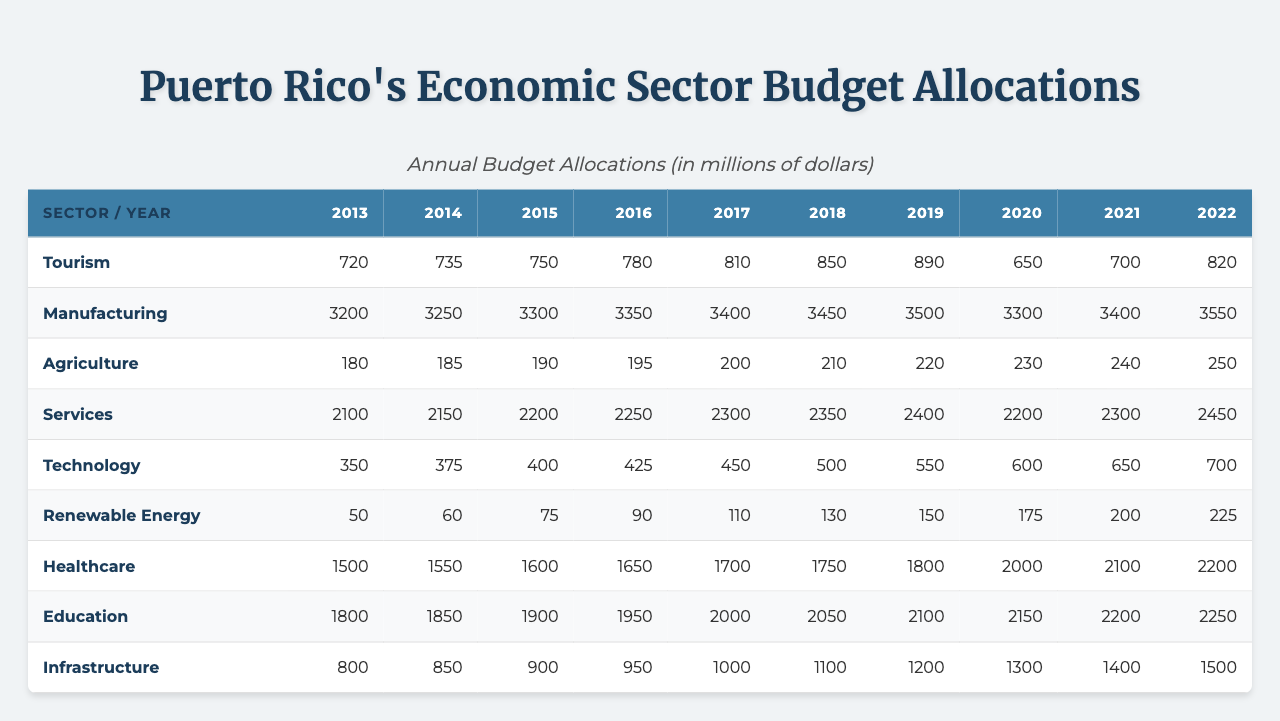What was the budget allocation for Healthcare in 2020? The table shows that the budget allocation for Healthcare in 2020 was 2000 million dollars.
Answer: 2000 million dollars In which year did the Agriculture sector see the highest budget allocation? The highest budget allocation for Agriculture was 250 million dollars in 2022, as observed in the table.
Answer: 2022 What was the total budget allocation for the Education sector from 2013 to 2022? By summing the values for Education from 2013 to 2022, (1800 + 1850 + 1900 + 1950 + 2000 + 2050 + 2100 + 2150 + 2200 + 2250) = 20,250 million dollars.
Answer: 20,250 million dollars Did the budget for Renewable Energy increase every year? The table indicates that the budget for Renewable Energy increased each year from 2013 to 2022, showing consistent growth.
Answer: Yes What is the average budget allocation for the Manufacturing sector over the decade? The total for Manufacturing is (3200 + 3250 + 3300 + 3350 + 3400 + 3450 + 3500 + 3300 + 3400 + 3550) = 34,600 million dollars; dividing this by the 10 years gives an average of 3460 million dollars.
Answer: 3460 million dollars Which sector had the lowest budget allocation in 2019? In 2019, the sector with the lowest budget allocation was Renewable Energy, with an allocation of 150 million dollars, as the table shows.
Answer: Renewable Energy How much more was allocated to the Services sector than the Agriculture sector in 2021? In 2021, the Services sector had an allocation of 2300 million dollars while Agriculture had 240 million dollars. The difference is (2300 - 240 = 2060) million dollars.
Answer: 2060 million dollars In which year did the Technology sector cross the 500 million dollar budget allocation? As per the table, the Technology sector crossed the 500 million dollar mark in 2018 when the allocation was 500 million dollars.
Answer: 2018 Was the budget for Tourism higher in 2022 than in 2013? In 2022, the budget for Tourism was 820 million dollars compared to 720 million dollars in 2013, therefore it is higher.
Answer: Yes What was the change in budget allocation for Infrastructure from 2013 to 2022? The allocation for Infrastructure increased from 800 million dollars in 2013 to 1500 million dollars in 2022, resulting in a change of (1500 - 800 = 700) million dollars.
Answer: 700 million dollars 